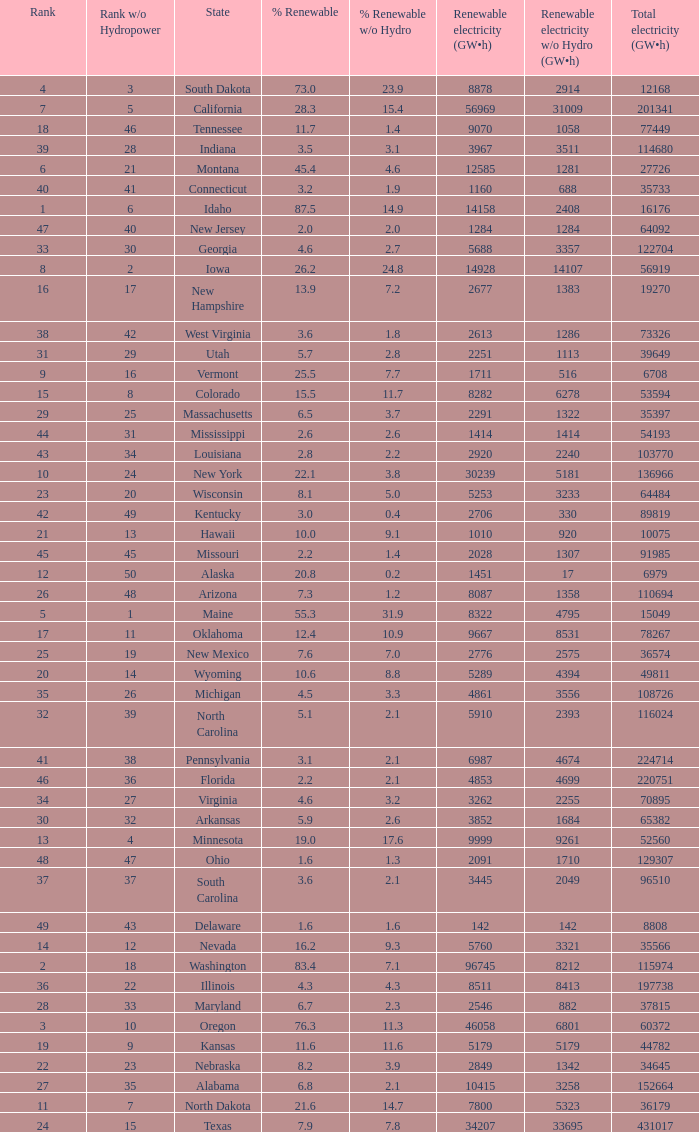Could you help me parse every detail presented in this table? {'header': ['Rank', 'Rank w/o Hydropower', 'State', '% Renewable', '% Renewable w/o Hydro', 'Renewable electricity (GW•h)', 'Renewable electricity w/o Hydro (GW•h)', 'Total electricity (GW•h)'], 'rows': [['4', '3', 'South Dakota', '73.0', '23.9', '8878', '2914', '12168'], ['7', '5', 'California', '28.3', '15.4', '56969', '31009', '201341'], ['18', '46', 'Tennessee', '11.7', '1.4', '9070', '1058', '77449'], ['39', '28', 'Indiana', '3.5', '3.1', '3967', '3511', '114680'], ['6', '21', 'Montana', '45.4', '4.6', '12585', '1281', '27726'], ['40', '41', 'Connecticut', '3.2', '1.9', '1160', '688', '35733'], ['1', '6', 'Idaho', '87.5', '14.9', '14158', '2408', '16176'], ['47', '40', 'New Jersey', '2.0', '2.0', '1284', '1284', '64092'], ['33', '30', 'Georgia', '4.6', '2.7', '5688', '3357', '122704'], ['8', '2', 'Iowa', '26.2', '24.8', '14928', '14107', '56919'], ['16', '17', 'New Hampshire', '13.9', '7.2', '2677', '1383', '19270'], ['38', '42', 'West Virginia', '3.6', '1.8', '2613', '1286', '73326'], ['31', '29', 'Utah', '5.7', '2.8', '2251', '1113', '39649'], ['9', '16', 'Vermont', '25.5', '7.7', '1711', '516', '6708'], ['15', '8', 'Colorado', '15.5', '11.7', '8282', '6278', '53594'], ['29', '25', 'Massachusetts', '6.5', '3.7', '2291', '1322', '35397'], ['44', '31', 'Mississippi', '2.6', '2.6', '1414', '1414', '54193'], ['43', '34', 'Louisiana', '2.8', '2.2', '2920', '2240', '103770'], ['10', '24', 'New York', '22.1', '3.8', '30239', '5181', '136966'], ['23', '20', 'Wisconsin', '8.1', '5.0', '5253', '3233', '64484'], ['42', '49', 'Kentucky', '3.0', '0.4', '2706', '330', '89819'], ['21', '13', 'Hawaii', '10.0', '9.1', '1010', '920', '10075'], ['45', '45', 'Missouri', '2.2', '1.4', '2028', '1307', '91985'], ['12', '50', 'Alaska', '20.8', '0.2', '1451', '17', '6979'], ['26', '48', 'Arizona', '7.3', '1.2', '8087', '1358', '110694'], ['5', '1', 'Maine', '55.3', '31.9', '8322', '4795', '15049'], ['17', '11', 'Oklahoma', '12.4', '10.9', '9667', '8531', '78267'], ['25', '19', 'New Mexico', '7.6', '7.0', '2776', '2575', '36574'], ['20', '14', 'Wyoming', '10.6', '8.8', '5289', '4394', '49811'], ['35', '26', 'Michigan', '4.5', '3.3', '4861', '3556', '108726'], ['32', '39', 'North Carolina', '5.1', '2.1', '5910', '2393', '116024'], ['41', '38', 'Pennsylvania', '3.1', '2.1', '6987', '4674', '224714'], ['46', '36', 'Florida', '2.2', '2.1', '4853', '4699', '220751'], ['34', '27', 'Virginia', '4.6', '3.2', '3262', '2255', '70895'], ['30', '32', 'Arkansas', '5.9', '2.6', '3852', '1684', '65382'], ['13', '4', 'Minnesota', '19.0', '17.6', '9999', '9261', '52560'], ['48', '47', 'Ohio', '1.6', '1.3', '2091', '1710', '129307'], ['37', '37', 'South Carolina', '3.6', '2.1', '3445', '2049', '96510'], ['49', '43', 'Delaware', '1.6', '1.6', '142', '142', '8808'], ['14', '12', 'Nevada', '16.2', '9.3', '5760', '3321', '35566'], ['2', '18', 'Washington', '83.4', '7.1', '96745', '8212', '115974'], ['36', '22', 'Illinois', '4.3', '4.3', '8511', '8413', '197738'], ['28', '33', 'Maryland', '6.7', '2.3', '2546', '882', '37815'], ['3', '10', 'Oregon', '76.3', '11.3', '46058', '6801', '60372'], ['19', '9', 'Kansas', '11.6', '11.6', '5179', '5179', '44782'], ['22', '23', 'Nebraska', '8.2', '3.9', '2849', '1342', '34645'], ['27', '35', 'Alabama', '6.8', '2.1', '10415', '3258', '152664'], ['11', '7', 'North Dakota', '21.6', '14.7', '7800', '5323', '36179'], ['24', '15', 'Texas', '7.9', '7.8', '34207', '33695', '431017']]} What is the maximum renewable energy (gw×h) for the state of Delaware? 142.0. 